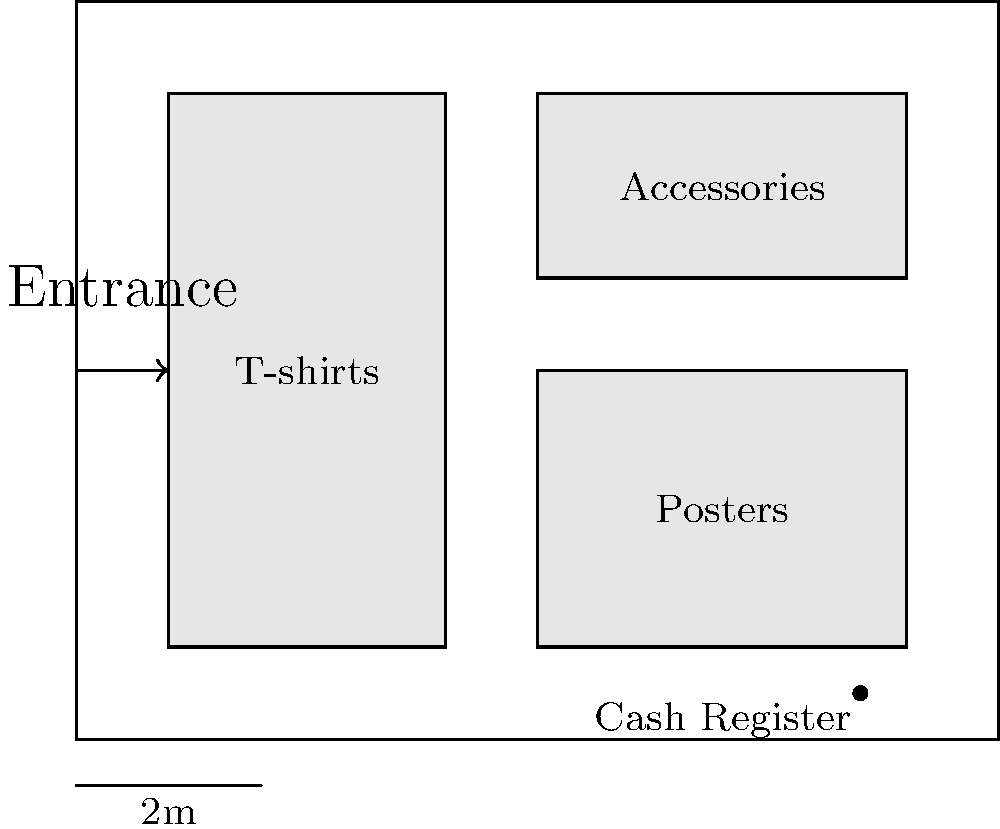You are planning the layout for a DRR merchandise booth at a convention. Given the floor plan above, what is the total area (in square meters) dedicated to displaying merchandise? To find the total area dedicated to displaying merchandise, we need to calculate the areas of the three display sections shown in the floor plan and sum them up. Let's go through this step-by-step:

1. T-shirts section:
   Width = 3 units (from 1 to 4 on the x-axis)
   Height = 6 units (from 1 to 7 on the y-axis)
   Area = 3 * 6 = 18 square units

2. Posters section:
   Width = 4 units (from 5 to 9 on the x-axis)
   Height = 3 units (from 1 to 4 on the y-axis)
   Area = 4 * 3 = 12 square units

3. Accessories section:
   Width = 4 units (from 5 to 9 on the x-axis)
   Height = 2 units (from 5 to 7 on the y-axis)
   Area = 4 * 2 = 8 square units

4. Total display area:
   Total = T-shirts + Posters + Accessories
   Total = 18 + 12 + 8 = 38 square units

5. Convert to square meters:
   The scale shows that 2 units = 2 meters
   So, 1 unit = 1 meter
   Therefore, 38 square units = 38 square meters

Thus, the total area dedicated to displaying merchandise is 38 square meters.
Answer: 38 m² 